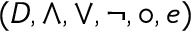Convert formula to latex. <formula><loc_0><loc_0><loc_500><loc_500>( D , \land , \lor , \ln o t , \circ , e )</formula> 